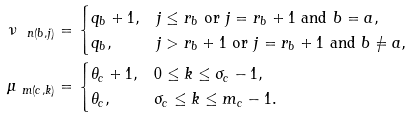<formula> <loc_0><loc_0><loc_500><loc_500>\nu _ { \ n ( b , j ) } & = \begin{cases} q _ { b } + 1 , & j \leq r _ { b } \text { or $j=r_{b}+1$ and $b=a$} , \\ q _ { b } , & j > r _ { b } + 1 \text { or $j= r_{b}+1$ and $b\neq a$,} \end{cases} \\ \mu _ { \ m ( c , k ) } & = \begin{cases} \theta _ { c } + 1 , & 0 \leq k \leq \sigma _ { c } - 1 , \\ \theta _ { c } , & \sigma _ { c } \leq k \leq m _ { c } - 1 . \end{cases}</formula> 